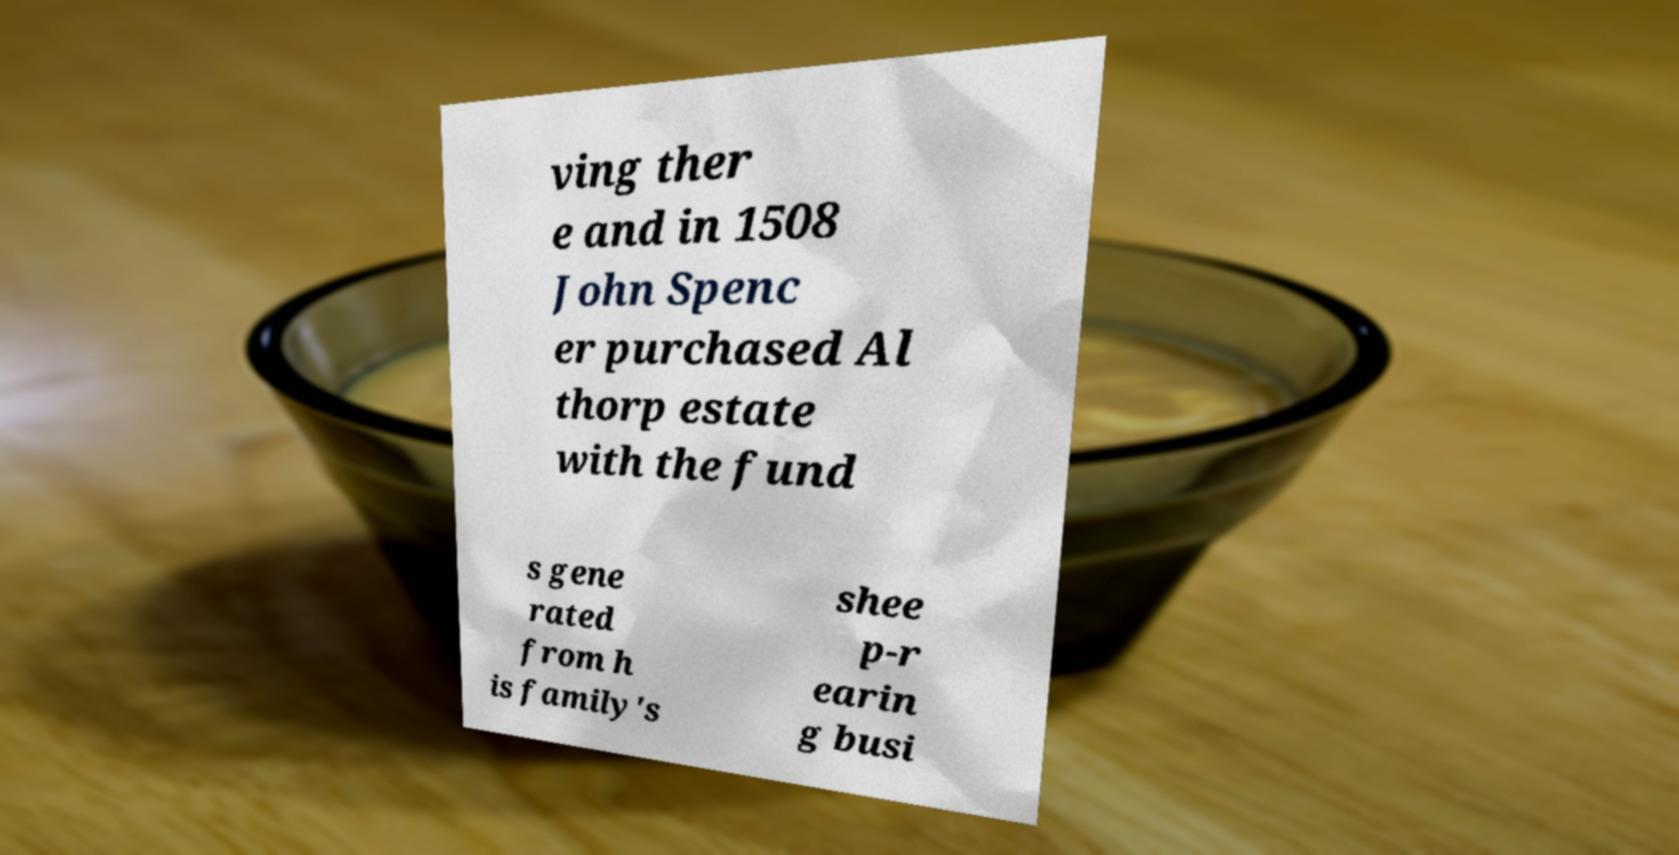For documentation purposes, I need the text within this image transcribed. Could you provide that? ving ther e and in 1508 John Spenc er purchased Al thorp estate with the fund s gene rated from h is family's shee p-r earin g busi 